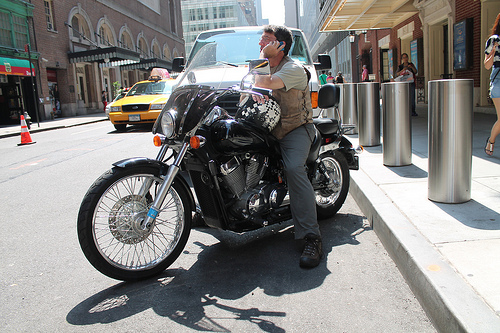Which kind of vehicle is to the left of the man? A yellow taxi is visible to the left of the man who is standing beside the motorcycle. 